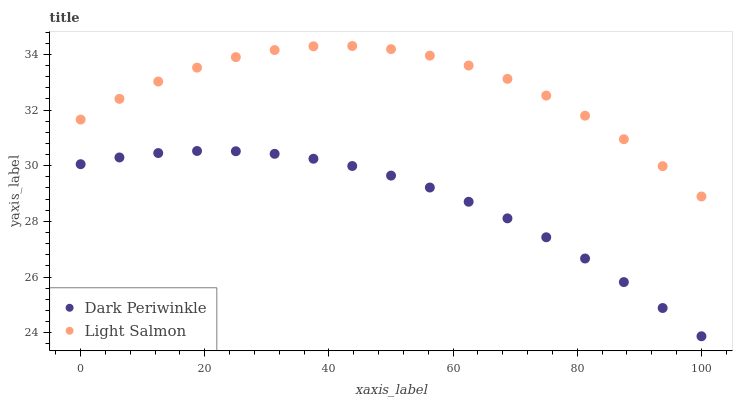Does Dark Periwinkle have the minimum area under the curve?
Answer yes or no. Yes. Does Light Salmon have the maximum area under the curve?
Answer yes or no. Yes. Does Dark Periwinkle have the maximum area under the curve?
Answer yes or no. No. Is Dark Periwinkle the smoothest?
Answer yes or no. Yes. Is Light Salmon the roughest?
Answer yes or no. Yes. Is Dark Periwinkle the roughest?
Answer yes or no. No. Does Dark Periwinkle have the lowest value?
Answer yes or no. Yes. Does Light Salmon have the highest value?
Answer yes or no. Yes. Does Dark Periwinkle have the highest value?
Answer yes or no. No. Is Dark Periwinkle less than Light Salmon?
Answer yes or no. Yes. Is Light Salmon greater than Dark Periwinkle?
Answer yes or no. Yes. Does Dark Periwinkle intersect Light Salmon?
Answer yes or no. No. 